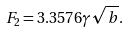Convert formula to latex. <formula><loc_0><loc_0><loc_500><loc_500>F _ { 2 } = 3 . 3 5 7 6 \gamma \sqrt { b } .</formula> 